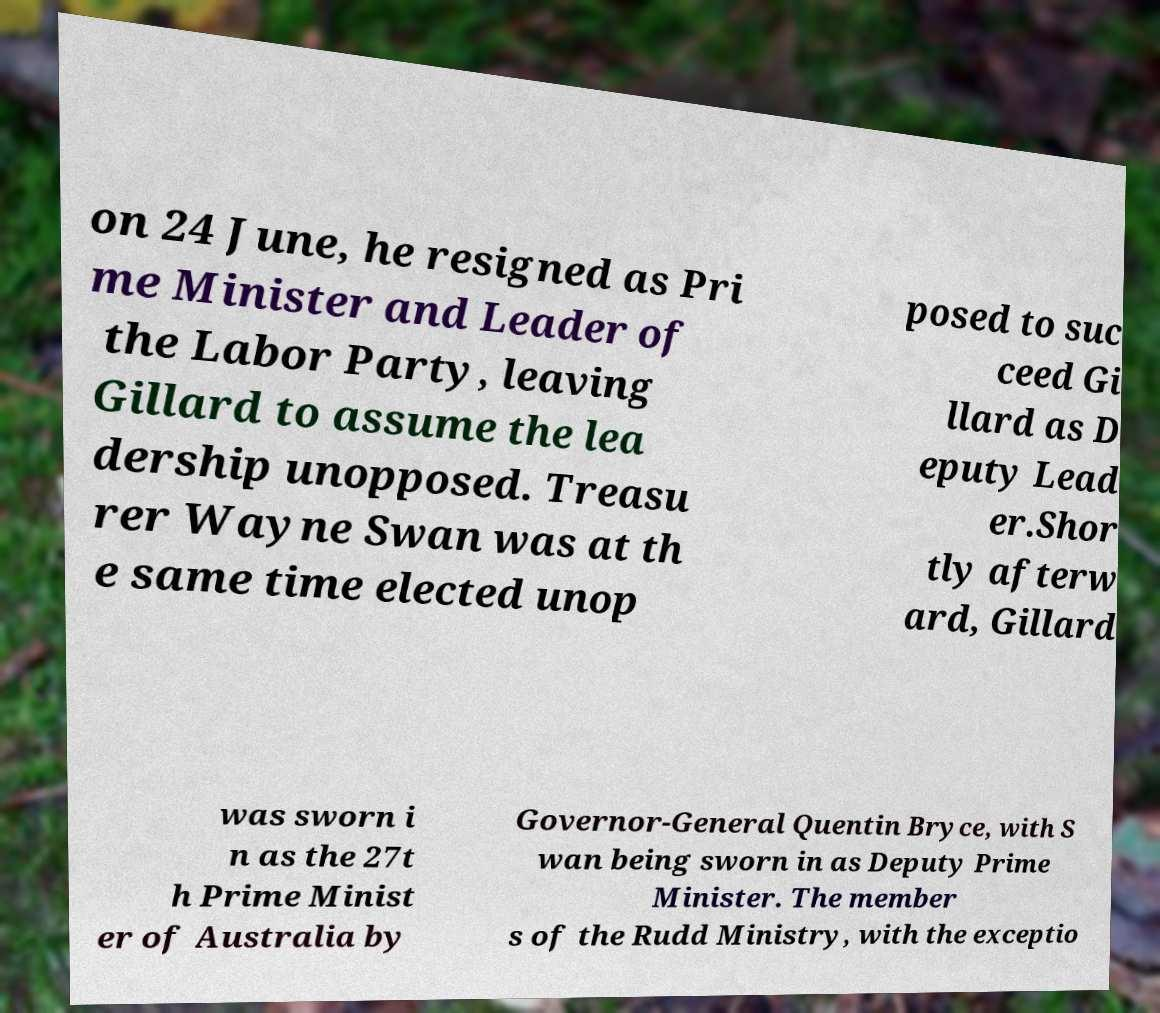Could you extract and type out the text from this image? on 24 June, he resigned as Pri me Minister and Leader of the Labor Party, leaving Gillard to assume the lea dership unopposed. Treasu rer Wayne Swan was at th e same time elected unop posed to suc ceed Gi llard as D eputy Lead er.Shor tly afterw ard, Gillard was sworn i n as the 27t h Prime Minist er of Australia by Governor-General Quentin Bryce, with S wan being sworn in as Deputy Prime Minister. The member s of the Rudd Ministry, with the exceptio 